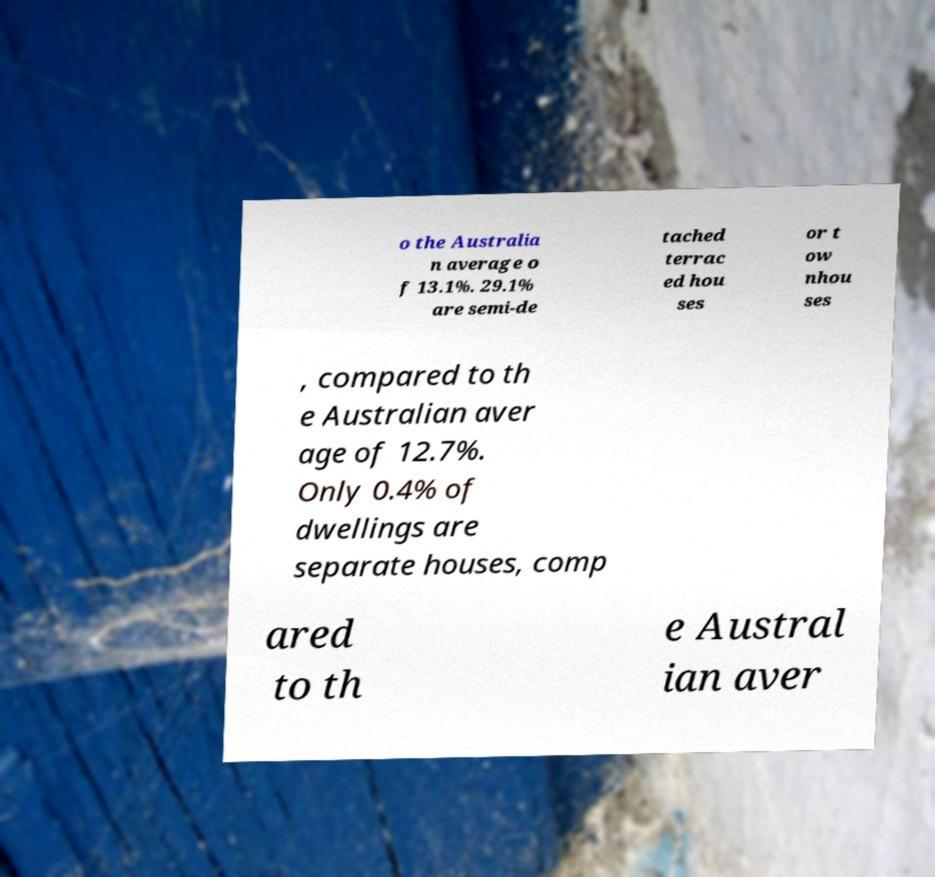Can you accurately transcribe the text from the provided image for me? o the Australia n average o f 13.1%. 29.1% are semi-de tached terrac ed hou ses or t ow nhou ses , compared to th e Australian aver age of 12.7%. Only 0.4% of dwellings are separate houses, comp ared to th e Austral ian aver 